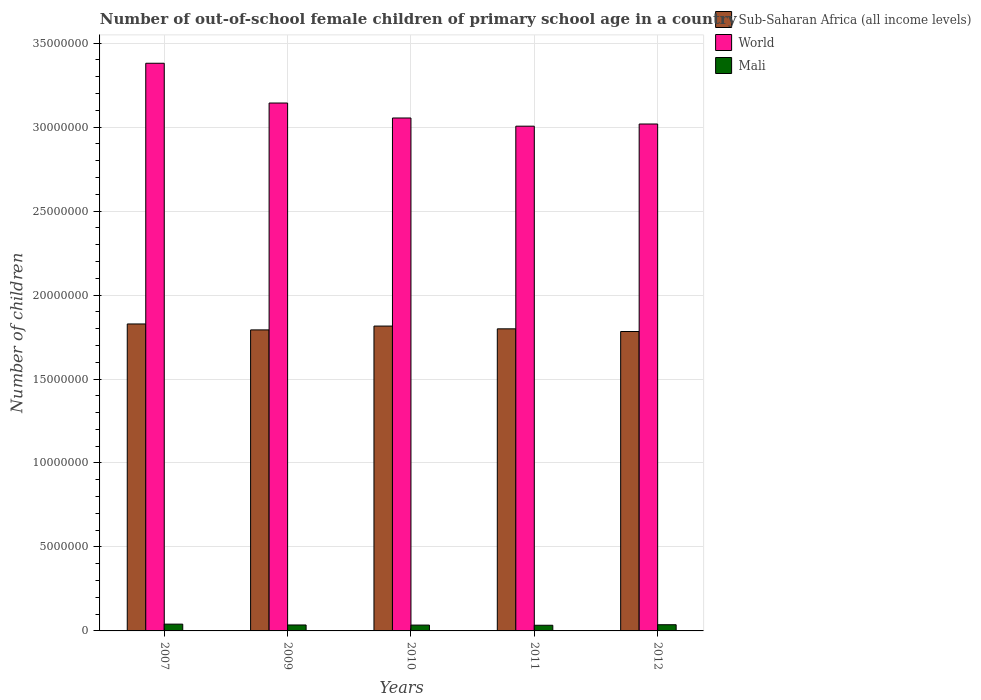How many different coloured bars are there?
Offer a very short reply. 3. How many groups of bars are there?
Ensure brevity in your answer.  5. Are the number of bars on each tick of the X-axis equal?
Make the answer very short. Yes. What is the number of out-of-school female children in World in 2011?
Make the answer very short. 3.01e+07. Across all years, what is the maximum number of out-of-school female children in Mali?
Your answer should be very brief. 4.04e+05. Across all years, what is the minimum number of out-of-school female children in Mali?
Ensure brevity in your answer.  3.37e+05. In which year was the number of out-of-school female children in World minimum?
Your response must be concise. 2011. What is the total number of out-of-school female children in Mali in the graph?
Your answer should be compact. 1.81e+06. What is the difference between the number of out-of-school female children in Sub-Saharan Africa (all income levels) in 2007 and that in 2010?
Provide a short and direct response. 1.26e+05. What is the difference between the number of out-of-school female children in Sub-Saharan Africa (all income levels) in 2011 and the number of out-of-school female children in World in 2010?
Your response must be concise. -1.26e+07. What is the average number of out-of-school female children in Sub-Saharan Africa (all income levels) per year?
Provide a succinct answer. 1.80e+07. In the year 2012, what is the difference between the number of out-of-school female children in Mali and number of out-of-school female children in World?
Your response must be concise. -2.98e+07. In how many years, is the number of out-of-school female children in Mali greater than 16000000?
Keep it short and to the point. 0. What is the ratio of the number of out-of-school female children in Sub-Saharan Africa (all income levels) in 2011 to that in 2012?
Provide a short and direct response. 1.01. Is the number of out-of-school female children in Sub-Saharan Africa (all income levels) in 2009 less than that in 2012?
Offer a terse response. No. What is the difference between the highest and the second highest number of out-of-school female children in Sub-Saharan Africa (all income levels)?
Provide a succinct answer. 1.26e+05. What is the difference between the highest and the lowest number of out-of-school female children in World?
Offer a very short reply. 3.75e+06. In how many years, is the number of out-of-school female children in Mali greater than the average number of out-of-school female children in Mali taken over all years?
Provide a short and direct response. 2. What does the 1st bar from the left in 2007 represents?
Make the answer very short. Sub-Saharan Africa (all income levels). What does the 2nd bar from the right in 2007 represents?
Your response must be concise. World. Is it the case that in every year, the sum of the number of out-of-school female children in World and number of out-of-school female children in Mali is greater than the number of out-of-school female children in Sub-Saharan Africa (all income levels)?
Ensure brevity in your answer.  Yes. How many years are there in the graph?
Offer a terse response. 5. Are the values on the major ticks of Y-axis written in scientific E-notation?
Your answer should be very brief. No. Does the graph contain grids?
Make the answer very short. Yes. How are the legend labels stacked?
Give a very brief answer. Vertical. What is the title of the graph?
Provide a succinct answer. Number of out-of-school female children of primary school age in a country. Does "Algeria" appear as one of the legend labels in the graph?
Ensure brevity in your answer.  No. What is the label or title of the Y-axis?
Your response must be concise. Number of children. What is the Number of children in Sub-Saharan Africa (all income levels) in 2007?
Provide a short and direct response. 1.83e+07. What is the Number of children of World in 2007?
Your response must be concise. 3.38e+07. What is the Number of children of Mali in 2007?
Your answer should be very brief. 4.04e+05. What is the Number of children of Sub-Saharan Africa (all income levels) in 2009?
Your answer should be compact. 1.79e+07. What is the Number of children in World in 2009?
Offer a very short reply. 3.14e+07. What is the Number of children of Mali in 2009?
Offer a very short reply. 3.54e+05. What is the Number of children in Sub-Saharan Africa (all income levels) in 2010?
Your answer should be very brief. 1.82e+07. What is the Number of children of World in 2010?
Offer a very short reply. 3.05e+07. What is the Number of children in Mali in 2010?
Keep it short and to the point. 3.47e+05. What is the Number of children in Sub-Saharan Africa (all income levels) in 2011?
Your answer should be very brief. 1.80e+07. What is the Number of children of World in 2011?
Offer a very short reply. 3.01e+07. What is the Number of children of Mali in 2011?
Give a very brief answer. 3.37e+05. What is the Number of children in Sub-Saharan Africa (all income levels) in 2012?
Offer a terse response. 1.78e+07. What is the Number of children of World in 2012?
Provide a short and direct response. 3.02e+07. What is the Number of children of Mali in 2012?
Your response must be concise. 3.69e+05. Across all years, what is the maximum Number of children of Sub-Saharan Africa (all income levels)?
Provide a short and direct response. 1.83e+07. Across all years, what is the maximum Number of children of World?
Your response must be concise. 3.38e+07. Across all years, what is the maximum Number of children of Mali?
Your answer should be very brief. 4.04e+05. Across all years, what is the minimum Number of children of Sub-Saharan Africa (all income levels)?
Offer a terse response. 1.78e+07. Across all years, what is the minimum Number of children in World?
Your answer should be very brief. 3.01e+07. Across all years, what is the minimum Number of children of Mali?
Offer a very short reply. 3.37e+05. What is the total Number of children of Sub-Saharan Africa (all income levels) in the graph?
Provide a short and direct response. 9.02e+07. What is the total Number of children in World in the graph?
Offer a very short reply. 1.56e+08. What is the total Number of children of Mali in the graph?
Give a very brief answer. 1.81e+06. What is the difference between the Number of children in Sub-Saharan Africa (all income levels) in 2007 and that in 2009?
Keep it short and to the point. 3.54e+05. What is the difference between the Number of children in World in 2007 and that in 2009?
Ensure brevity in your answer.  2.37e+06. What is the difference between the Number of children of Mali in 2007 and that in 2009?
Provide a succinct answer. 4.99e+04. What is the difference between the Number of children of Sub-Saharan Africa (all income levels) in 2007 and that in 2010?
Offer a very short reply. 1.26e+05. What is the difference between the Number of children of World in 2007 and that in 2010?
Make the answer very short. 3.26e+06. What is the difference between the Number of children of Mali in 2007 and that in 2010?
Provide a short and direct response. 5.69e+04. What is the difference between the Number of children of Sub-Saharan Africa (all income levels) in 2007 and that in 2011?
Provide a short and direct response. 2.90e+05. What is the difference between the Number of children of World in 2007 and that in 2011?
Provide a short and direct response. 3.75e+06. What is the difference between the Number of children of Mali in 2007 and that in 2011?
Your answer should be compact. 6.71e+04. What is the difference between the Number of children in Sub-Saharan Africa (all income levels) in 2007 and that in 2012?
Your answer should be very brief. 4.50e+05. What is the difference between the Number of children of World in 2007 and that in 2012?
Your answer should be very brief. 3.62e+06. What is the difference between the Number of children in Mali in 2007 and that in 2012?
Offer a terse response. 3.50e+04. What is the difference between the Number of children of Sub-Saharan Africa (all income levels) in 2009 and that in 2010?
Provide a succinct answer. -2.28e+05. What is the difference between the Number of children of World in 2009 and that in 2010?
Give a very brief answer. 8.92e+05. What is the difference between the Number of children in Mali in 2009 and that in 2010?
Provide a short and direct response. 7084. What is the difference between the Number of children of Sub-Saharan Africa (all income levels) in 2009 and that in 2011?
Offer a terse response. -6.33e+04. What is the difference between the Number of children of World in 2009 and that in 2011?
Your response must be concise. 1.38e+06. What is the difference between the Number of children of Mali in 2009 and that in 2011?
Your response must be concise. 1.72e+04. What is the difference between the Number of children in Sub-Saharan Africa (all income levels) in 2009 and that in 2012?
Your response must be concise. 9.59e+04. What is the difference between the Number of children of World in 2009 and that in 2012?
Offer a very short reply. 1.25e+06. What is the difference between the Number of children of Mali in 2009 and that in 2012?
Ensure brevity in your answer.  -1.49e+04. What is the difference between the Number of children of Sub-Saharan Africa (all income levels) in 2010 and that in 2011?
Make the answer very short. 1.65e+05. What is the difference between the Number of children of World in 2010 and that in 2011?
Provide a succinct answer. 4.87e+05. What is the difference between the Number of children of Mali in 2010 and that in 2011?
Offer a very short reply. 1.01e+04. What is the difference between the Number of children in Sub-Saharan Africa (all income levels) in 2010 and that in 2012?
Make the answer very short. 3.24e+05. What is the difference between the Number of children of World in 2010 and that in 2012?
Provide a short and direct response. 3.58e+05. What is the difference between the Number of children in Mali in 2010 and that in 2012?
Keep it short and to the point. -2.19e+04. What is the difference between the Number of children of Sub-Saharan Africa (all income levels) in 2011 and that in 2012?
Make the answer very short. 1.59e+05. What is the difference between the Number of children in World in 2011 and that in 2012?
Your answer should be compact. -1.29e+05. What is the difference between the Number of children of Mali in 2011 and that in 2012?
Your response must be concise. -3.21e+04. What is the difference between the Number of children in Sub-Saharan Africa (all income levels) in 2007 and the Number of children in World in 2009?
Offer a very short reply. -1.32e+07. What is the difference between the Number of children in Sub-Saharan Africa (all income levels) in 2007 and the Number of children in Mali in 2009?
Offer a terse response. 1.79e+07. What is the difference between the Number of children of World in 2007 and the Number of children of Mali in 2009?
Give a very brief answer. 3.34e+07. What is the difference between the Number of children in Sub-Saharan Africa (all income levels) in 2007 and the Number of children in World in 2010?
Keep it short and to the point. -1.23e+07. What is the difference between the Number of children in Sub-Saharan Africa (all income levels) in 2007 and the Number of children in Mali in 2010?
Offer a terse response. 1.79e+07. What is the difference between the Number of children in World in 2007 and the Number of children in Mali in 2010?
Make the answer very short. 3.35e+07. What is the difference between the Number of children in Sub-Saharan Africa (all income levels) in 2007 and the Number of children in World in 2011?
Give a very brief answer. -1.18e+07. What is the difference between the Number of children of Sub-Saharan Africa (all income levels) in 2007 and the Number of children of Mali in 2011?
Offer a terse response. 1.79e+07. What is the difference between the Number of children of World in 2007 and the Number of children of Mali in 2011?
Give a very brief answer. 3.35e+07. What is the difference between the Number of children in Sub-Saharan Africa (all income levels) in 2007 and the Number of children in World in 2012?
Your response must be concise. -1.19e+07. What is the difference between the Number of children of Sub-Saharan Africa (all income levels) in 2007 and the Number of children of Mali in 2012?
Make the answer very short. 1.79e+07. What is the difference between the Number of children of World in 2007 and the Number of children of Mali in 2012?
Your response must be concise. 3.34e+07. What is the difference between the Number of children of Sub-Saharan Africa (all income levels) in 2009 and the Number of children of World in 2010?
Give a very brief answer. -1.26e+07. What is the difference between the Number of children in Sub-Saharan Africa (all income levels) in 2009 and the Number of children in Mali in 2010?
Offer a very short reply. 1.76e+07. What is the difference between the Number of children of World in 2009 and the Number of children of Mali in 2010?
Offer a terse response. 3.11e+07. What is the difference between the Number of children of Sub-Saharan Africa (all income levels) in 2009 and the Number of children of World in 2011?
Provide a short and direct response. -1.21e+07. What is the difference between the Number of children of Sub-Saharan Africa (all income levels) in 2009 and the Number of children of Mali in 2011?
Your answer should be very brief. 1.76e+07. What is the difference between the Number of children in World in 2009 and the Number of children in Mali in 2011?
Offer a very short reply. 3.11e+07. What is the difference between the Number of children of Sub-Saharan Africa (all income levels) in 2009 and the Number of children of World in 2012?
Make the answer very short. -1.23e+07. What is the difference between the Number of children of Sub-Saharan Africa (all income levels) in 2009 and the Number of children of Mali in 2012?
Your answer should be very brief. 1.76e+07. What is the difference between the Number of children in World in 2009 and the Number of children in Mali in 2012?
Ensure brevity in your answer.  3.11e+07. What is the difference between the Number of children of Sub-Saharan Africa (all income levels) in 2010 and the Number of children of World in 2011?
Your response must be concise. -1.19e+07. What is the difference between the Number of children in Sub-Saharan Africa (all income levels) in 2010 and the Number of children in Mali in 2011?
Provide a short and direct response. 1.78e+07. What is the difference between the Number of children in World in 2010 and the Number of children in Mali in 2011?
Provide a short and direct response. 3.02e+07. What is the difference between the Number of children in Sub-Saharan Africa (all income levels) in 2010 and the Number of children in World in 2012?
Offer a terse response. -1.20e+07. What is the difference between the Number of children in Sub-Saharan Africa (all income levels) in 2010 and the Number of children in Mali in 2012?
Your response must be concise. 1.78e+07. What is the difference between the Number of children of World in 2010 and the Number of children of Mali in 2012?
Ensure brevity in your answer.  3.02e+07. What is the difference between the Number of children in Sub-Saharan Africa (all income levels) in 2011 and the Number of children in World in 2012?
Offer a terse response. -1.22e+07. What is the difference between the Number of children in Sub-Saharan Africa (all income levels) in 2011 and the Number of children in Mali in 2012?
Your answer should be very brief. 1.76e+07. What is the difference between the Number of children of World in 2011 and the Number of children of Mali in 2012?
Your answer should be compact. 2.97e+07. What is the average Number of children in Sub-Saharan Africa (all income levels) per year?
Keep it short and to the point. 1.80e+07. What is the average Number of children in World per year?
Keep it short and to the point. 3.12e+07. What is the average Number of children in Mali per year?
Offer a very short reply. 3.62e+05. In the year 2007, what is the difference between the Number of children in Sub-Saharan Africa (all income levels) and Number of children in World?
Your answer should be compact. -1.55e+07. In the year 2007, what is the difference between the Number of children of Sub-Saharan Africa (all income levels) and Number of children of Mali?
Make the answer very short. 1.79e+07. In the year 2007, what is the difference between the Number of children of World and Number of children of Mali?
Your answer should be very brief. 3.34e+07. In the year 2009, what is the difference between the Number of children in Sub-Saharan Africa (all income levels) and Number of children in World?
Provide a succinct answer. -1.35e+07. In the year 2009, what is the difference between the Number of children in Sub-Saharan Africa (all income levels) and Number of children in Mali?
Ensure brevity in your answer.  1.76e+07. In the year 2009, what is the difference between the Number of children of World and Number of children of Mali?
Your answer should be compact. 3.11e+07. In the year 2010, what is the difference between the Number of children in Sub-Saharan Africa (all income levels) and Number of children in World?
Offer a very short reply. -1.24e+07. In the year 2010, what is the difference between the Number of children in Sub-Saharan Africa (all income levels) and Number of children in Mali?
Your response must be concise. 1.78e+07. In the year 2010, what is the difference between the Number of children in World and Number of children in Mali?
Keep it short and to the point. 3.02e+07. In the year 2011, what is the difference between the Number of children of Sub-Saharan Africa (all income levels) and Number of children of World?
Make the answer very short. -1.21e+07. In the year 2011, what is the difference between the Number of children of Sub-Saharan Africa (all income levels) and Number of children of Mali?
Ensure brevity in your answer.  1.77e+07. In the year 2011, what is the difference between the Number of children in World and Number of children in Mali?
Provide a short and direct response. 2.97e+07. In the year 2012, what is the difference between the Number of children in Sub-Saharan Africa (all income levels) and Number of children in World?
Your answer should be very brief. -1.24e+07. In the year 2012, what is the difference between the Number of children in Sub-Saharan Africa (all income levels) and Number of children in Mali?
Ensure brevity in your answer.  1.75e+07. In the year 2012, what is the difference between the Number of children in World and Number of children in Mali?
Offer a terse response. 2.98e+07. What is the ratio of the Number of children of Sub-Saharan Africa (all income levels) in 2007 to that in 2009?
Your answer should be very brief. 1.02. What is the ratio of the Number of children of World in 2007 to that in 2009?
Make the answer very short. 1.08. What is the ratio of the Number of children in Mali in 2007 to that in 2009?
Keep it short and to the point. 1.14. What is the ratio of the Number of children of World in 2007 to that in 2010?
Your response must be concise. 1.11. What is the ratio of the Number of children of Mali in 2007 to that in 2010?
Your answer should be very brief. 1.16. What is the ratio of the Number of children in Sub-Saharan Africa (all income levels) in 2007 to that in 2011?
Your response must be concise. 1.02. What is the ratio of the Number of children of World in 2007 to that in 2011?
Provide a short and direct response. 1.12. What is the ratio of the Number of children in Mali in 2007 to that in 2011?
Provide a short and direct response. 1.2. What is the ratio of the Number of children of Sub-Saharan Africa (all income levels) in 2007 to that in 2012?
Provide a succinct answer. 1.03. What is the ratio of the Number of children in World in 2007 to that in 2012?
Your response must be concise. 1.12. What is the ratio of the Number of children in Mali in 2007 to that in 2012?
Your answer should be very brief. 1.09. What is the ratio of the Number of children in Sub-Saharan Africa (all income levels) in 2009 to that in 2010?
Make the answer very short. 0.99. What is the ratio of the Number of children in World in 2009 to that in 2010?
Ensure brevity in your answer.  1.03. What is the ratio of the Number of children of Mali in 2009 to that in 2010?
Ensure brevity in your answer.  1.02. What is the ratio of the Number of children in Sub-Saharan Africa (all income levels) in 2009 to that in 2011?
Give a very brief answer. 1. What is the ratio of the Number of children in World in 2009 to that in 2011?
Your response must be concise. 1.05. What is the ratio of the Number of children in Mali in 2009 to that in 2011?
Your answer should be very brief. 1.05. What is the ratio of the Number of children of Sub-Saharan Africa (all income levels) in 2009 to that in 2012?
Make the answer very short. 1.01. What is the ratio of the Number of children of World in 2009 to that in 2012?
Ensure brevity in your answer.  1.04. What is the ratio of the Number of children of Mali in 2009 to that in 2012?
Provide a short and direct response. 0.96. What is the ratio of the Number of children of Sub-Saharan Africa (all income levels) in 2010 to that in 2011?
Your answer should be very brief. 1.01. What is the ratio of the Number of children of World in 2010 to that in 2011?
Offer a terse response. 1.02. What is the ratio of the Number of children of Sub-Saharan Africa (all income levels) in 2010 to that in 2012?
Your answer should be very brief. 1.02. What is the ratio of the Number of children in World in 2010 to that in 2012?
Make the answer very short. 1.01. What is the ratio of the Number of children of Mali in 2010 to that in 2012?
Your answer should be very brief. 0.94. What is the ratio of the Number of children of Sub-Saharan Africa (all income levels) in 2011 to that in 2012?
Offer a very short reply. 1.01. What is the ratio of the Number of children of World in 2011 to that in 2012?
Make the answer very short. 1. What is the ratio of the Number of children in Mali in 2011 to that in 2012?
Provide a succinct answer. 0.91. What is the difference between the highest and the second highest Number of children of Sub-Saharan Africa (all income levels)?
Offer a very short reply. 1.26e+05. What is the difference between the highest and the second highest Number of children in World?
Your response must be concise. 2.37e+06. What is the difference between the highest and the second highest Number of children of Mali?
Your response must be concise. 3.50e+04. What is the difference between the highest and the lowest Number of children in Sub-Saharan Africa (all income levels)?
Make the answer very short. 4.50e+05. What is the difference between the highest and the lowest Number of children in World?
Your answer should be very brief. 3.75e+06. What is the difference between the highest and the lowest Number of children of Mali?
Your answer should be compact. 6.71e+04. 